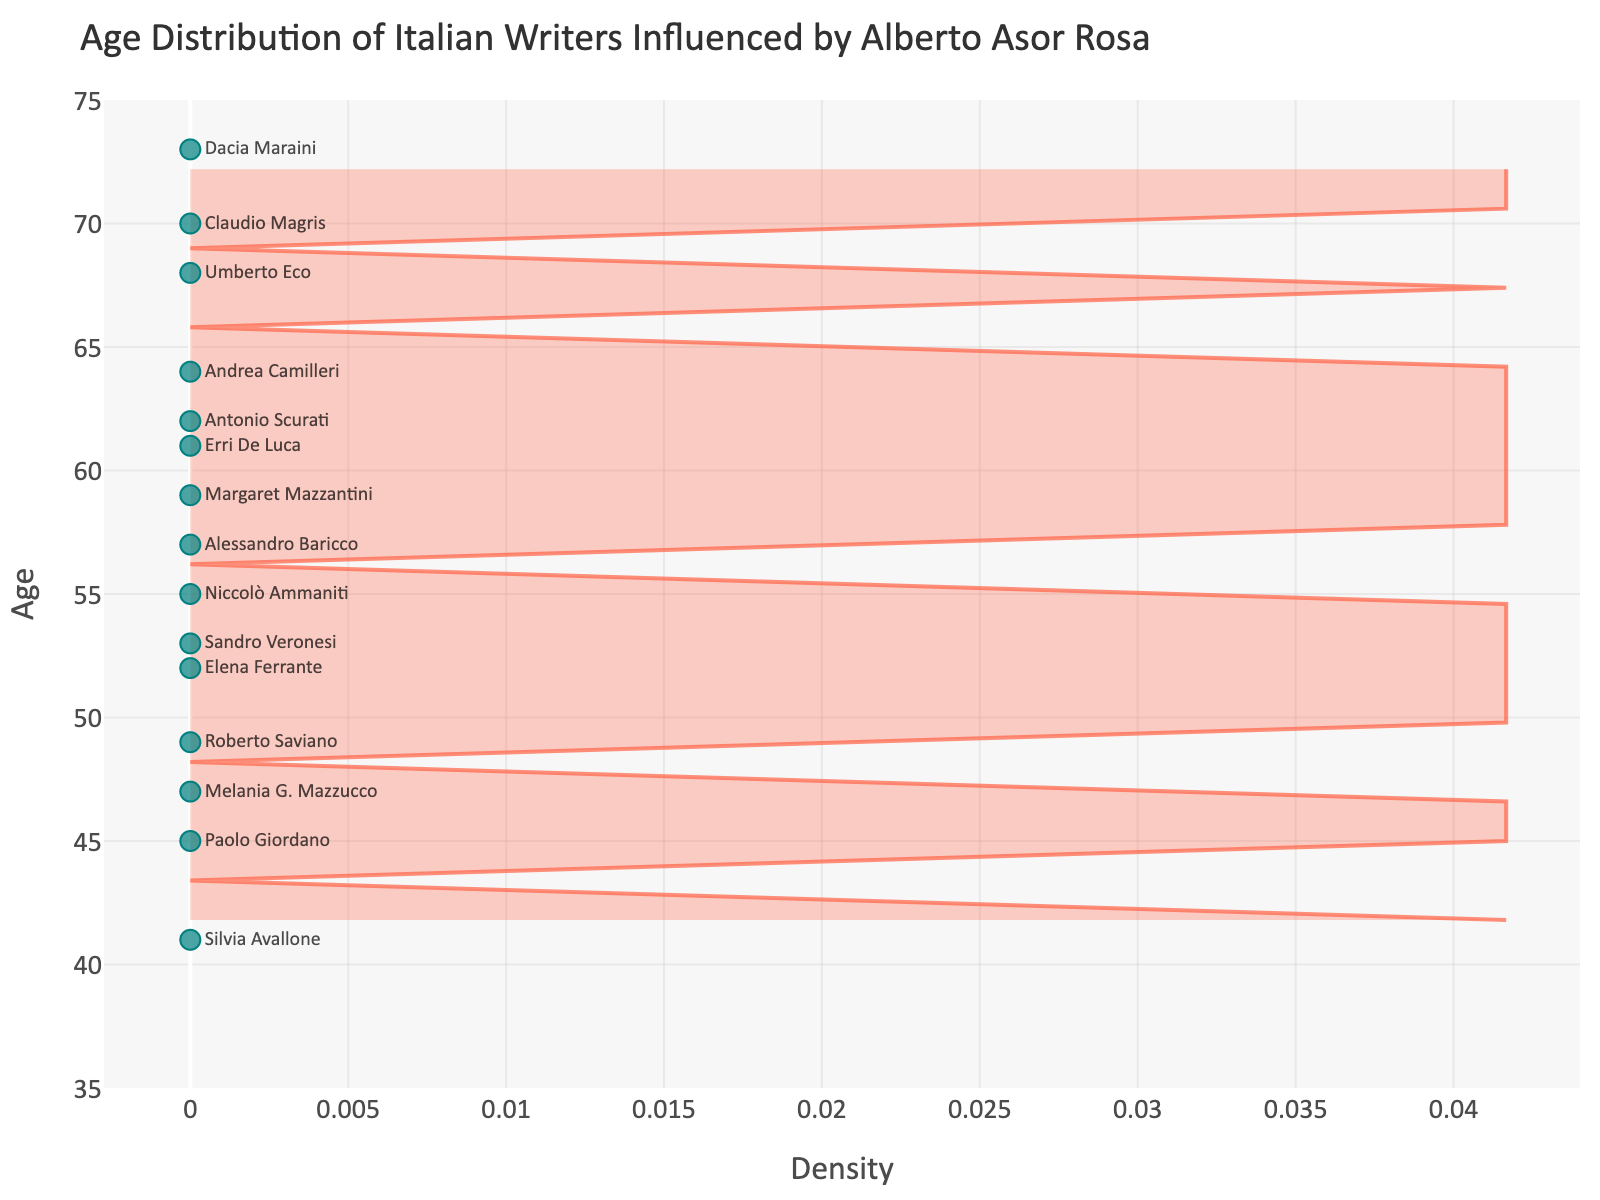What's the title of the plot? The title is mentioned at the top of the plot. It reads, "Age Distribution of Italian Writers Influenced by Alberto Asor Rosa."
Answer: Age Distribution of Italian Writers Influenced by Alberto Asor Rosa How many data points are there? Each writer is represented by a marker in the plot. By counting the markers or referencing the dataset, we see there are 15 writers.
Answer: 15 What is the youngest age of the writers? The youngest writer can be identified by the lowest point on the y-axis. The age is 41.
Answer: 41 What is the oldest age of the writers? The oldest writer is identified by the highest point on the y-axis. The age is 73.
Answer: 73 What age range is most densely populated? The peak of the density curve highlights the range where most ages are concentrated. The peak appears to be around ages 55 to 65.
Answer: 55 to 65 How many writers are older than 60? By counting the markers above the y-axis value of 60, we identify that there are six writers.
Answer: 6 Compare the ages of Umberto Eco and Roberto Saviano. Who is older? Umberto Eco's age is 68 and Roberto Saviano's age is 49. Comparing these values, Umberto Eco is older.
Answer: Umberto Eco What's the median age of the writers? To find the median age, we list all ages in ascending order and find the middle value. The ages are 41, 45, 47, 49, 52, 53, 55, 57, 59, 61, 62, 64, 68, 70, 73. The median age is the 8th value, which is 57.
Answer: 57 How many writers are in their 50s? We count the markers that fall within the y-axis range 50-59. The ages 52, 53, 55, 57, and 59 fall within this range. There are 5 writers.
Answer: 5 Which writer is closest in age to 50? By looking at the plot and comparing the ages close to 50, the closest age is 49, which corresponds to Roberto Saviano.
Answer: Roberto Saviano 